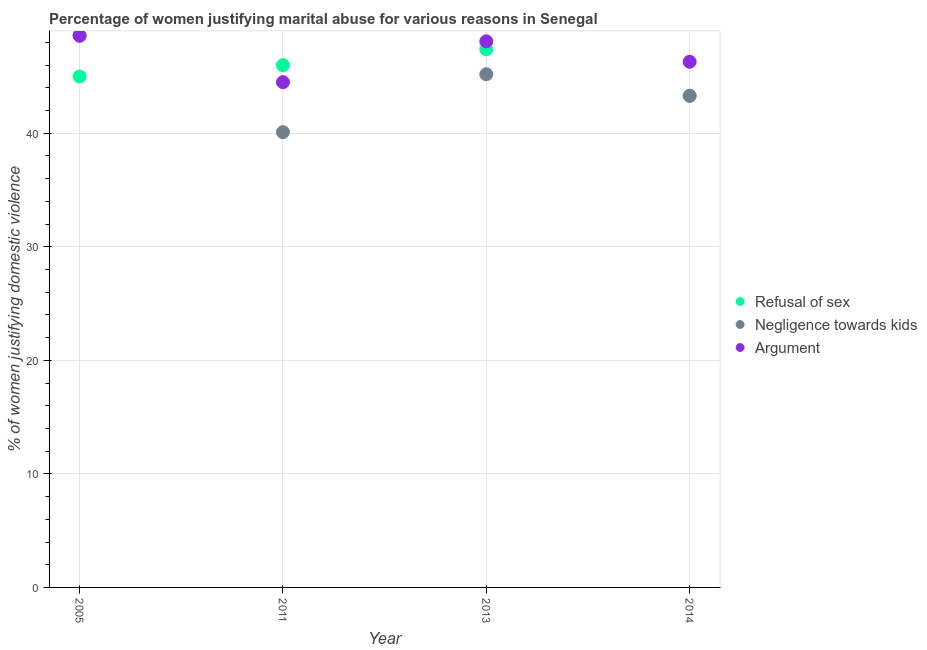What is the percentage of women justifying domestic violence due to arguments in 2011?
Ensure brevity in your answer.  44.5. Across all years, what is the maximum percentage of women justifying domestic violence due to refusal of sex?
Give a very brief answer. 47.4. Across all years, what is the minimum percentage of women justifying domestic violence due to refusal of sex?
Keep it short and to the point. 43.3. In which year was the percentage of women justifying domestic violence due to negligence towards kids maximum?
Your response must be concise. 2005. What is the total percentage of women justifying domestic violence due to arguments in the graph?
Make the answer very short. 187.5. What is the difference between the percentage of women justifying domestic violence due to negligence towards kids in 2011 and that in 2014?
Keep it short and to the point. -3.2. What is the difference between the percentage of women justifying domestic violence due to refusal of sex in 2011 and the percentage of women justifying domestic violence due to negligence towards kids in 2013?
Offer a terse response. 0.8. What is the average percentage of women justifying domestic violence due to negligence towards kids per year?
Your response must be concise. 44.3. In the year 2013, what is the difference between the percentage of women justifying domestic violence due to negligence towards kids and percentage of women justifying domestic violence due to arguments?
Offer a terse response. -2.9. In how many years, is the percentage of women justifying domestic violence due to negligence towards kids greater than 28 %?
Provide a succinct answer. 4. What is the ratio of the percentage of women justifying domestic violence due to negligence towards kids in 2005 to that in 2013?
Your response must be concise. 1.08. Is the difference between the percentage of women justifying domestic violence due to refusal of sex in 2011 and 2013 greater than the difference between the percentage of women justifying domestic violence due to arguments in 2011 and 2013?
Ensure brevity in your answer.  Yes. What is the difference between the highest and the second highest percentage of women justifying domestic violence due to arguments?
Your response must be concise. 0.5. What is the difference between the highest and the lowest percentage of women justifying domestic violence due to negligence towards kids?
Offer a very short reply. 8.5. Is it the case that in every year, the sum of the percentage of women justifying domestic violence due to refusal of sex and percentage of women justifying domestic violence due to negligence towards kids is greater than the percentage of women justifying domestic violence due to arguments?
Give a very brief answer. Yes. How many dotlines are there?
Your response must be concise. 3. How many years are there in the graph?
Keep it short and to the point. 4. What is the difference between two consecutive major ticks on the Y-axis?
Make the answer very short. 10. How many legend labels are there?
Make the answer very short. 3. How are the legend labels stacked?
Your response must be concise. Vertical. What is the title of the graph?
Ensure brevity in your answer.  Percentage of women justifying marital abuse for various reasons in Senegal. What is the label or title of the Y-axis?
Offer a terse response. % of women justifying domestic violence. What is the % of women justifying domestic violence of Refusal of sex in 2005?
Give a very brief answer. 45. What is the % of women justifying domestic violence in Negligence towards kids in 2005?
Give a very brief answer. 48.6. What is the % of women justifying domestic violence of Argument in 2005?
Provide a succinct answer. 48.6. What is the % of women justifying domestic violence in Negligence towards kids in 2011?
Ensure brevity in your answer.  40.1. What is the % of women justifying domestic violence in Argument in 2011?
Make the answer very short. 44.5. What is the % of women justifying domestic violence of Refusal of sex in 2013?
Give a very brief answer. 47.4. What is the % of women justifying domestic violence of Negligence towards kids in 2013?
Offer a terse response. 45.2. What is the % of women justifying domestic violence of Argument in 2013?
Make the answer very short. 48.1. What is the % of women justifying domestic violence of Refusal of sex in 2014?
Provide a short and direct response. 43.3. What is the % of women justifying domestic violence of Negligence towards kids in 2014?
Offer a terse response. 43.3. What is the % of women justifying domestic violence of Argument in 2014?
Your answer should be compact. 46.3. Across all years, what is the maximum % of women justifying domestic violence in Refusal of sex?
Your answer should be compact. 47.4. Across all years, what is the maximum % of women justifying domestic violence in Negligence towards kids?
Offer a very short reply. 48.6. Across all years, what is the maximum % of women justifying domestic violence of Argument?
Offer a very short reply. 48.6. Across all years, what is the minimum % of women justifying domestic violence of Refusal of sex?
Provide a succinct answer. 43.3. Across all years, what is the minimum % of women justifying domestic violence of Negligence towards kids?
Make the answer very short. 40.1. Across all years, what is the minimum % of women justifying domestic violence of Argument?
Give a very brief answer. 44.5. What is the total % of women justifying domestic violence of Refusal of sex in the graph?
Keep it short and to the point. 181.7. What is the total % of women justifying domestic violence in Negligence towards kids in the graph?
Make the answer very short. 177.2. What is the total % of women justifying domestic violence in Argument in the graph?
Give a very brief answer. 187.5. What is the difference between the % of women justifying domestic violence of Refusal of sex in 2005 and that in 2011?
Offer a very short reply. -1. What is the difference between the % of women justifying domestic violence in Refusal of sex in 2005 and that in 2013?
Your answer should be very brief. -2.4. What is the difference between the % of women justifying domestic violence of Argument in 2005 and that in 2013?
Ensure brevity in your answer.  0.5. What is the difference between the % of women justifying domestic violence in Argument in 2005 and that in 2014?
Offer a very short reply. 2.3. What is the difference between the % of women justifying domestic violence of Argument in 2011 and that in 2013?
Keep it short and to the point. -3.6. What is the difference between the % of women justifying domestic violence of Argument in 2011 and that in 2014?
Your response must be concise. -1.8. What is the difference between the % of women justifying domestic violence of Argument in 2013 and that in 2014?
Ensure brevity in your answer.  1.8. What is the difference between the % of women justifying domestic violence of Refusal of sex in 2005 and the % of women justifying domestic violence of Negligence towards kids in 2013?
Provide a short and direct response. -0.2. What is the difference between the % of women justifying domestic violence in Refusal of sex in 2005 and the % of women justifying domestic violence in Negligence towards kids in 2014?
Provide a succinct answer. 1.7. What is the difference between the % of women justifying domestic violence of Refusal of sex in 2005 and the % of women justifying domestic violence of Argument in 2014?
Keep it short and to the point. -1.3. What is the difference between the % of women justifying domestic violence of Refusal of sex in 2011 and the % of women justifying domestic violence of Negligence towards kids in 2013?
Make the answer very short. 0.8. What is the difference between the % of women justifying domestic violence of Refusal of sex in 2011 and the % of women justifying domestic violence of Negligence towards kids in 2014?
Give a very brief answer. 2.7. What is the difference between the % of women justifying domestic violence in Refusal of sex in 2011 and the % of women justifying domestic violence in Argument in 2014?
Give a very brief answer. -0.3. What is the average % of women justifying domestic violence of Refusal of sex per year?
Provide a succinct answer. 45.42. What is the average % of women justifying domestic violence in Negligence towards kids per year?
Offer a very short reply. 44.3. What is the average % of women justifying domestic violence in Argument per year?
Ensure brevity in your answer.  46.88. In the year 2005, what is the difference between the % of women justifying domestic violence in Refusal of sex and % of women justifying domestic violence in Negligence towards kids?
Give a very brief answer. -3.6. In the year 2005, what is the difference between the % of women justifying domestic violence in Refusal of sex and % of women justifying domestic violence in Argument?
Your answer should be very brief. -3.6. In the year 2005, what is the difference between the % of women justifying domestic violence of Negligence towards kids and % of women justifying domestic violence of Argument?
Offer a terse response. 0. In the year 2011, what is the difference between the % of women justifying domestic violence of Refusal of sex and % of women justifying domestic violence of Negligence towards kids?
Ensure brevity in your answer.  5.9. In the year 2011, what is the difference between the % of women justifying domestic violence of Negligence towards kids and % of women justifying domestic violence of Argument?
Provide a succinct answer. -4.4. In the year 2013, what is the difference between the % of women justifying domestic violence in Negligence towards kids and % of women justifying domestic violence in Argument?
Offer a very short reply. -2.9. In the year 2014, what is the difference between the % of women justifying domestic violence of Refusal of sex and % of women justifying domestic violence of Negligence towards kids?
Ensure brevity in your answer.  0. What is the ratio of the % of women justifying domestic violence in Refusal of sex in 2005 to that in 2011?
Give a very brief answer. 0.98. What is the ratio of the % of women justifying domestic violence of Negligence towards kids in 2005 to that in 2011?
Provide a short and direct response. 1.21. What is the ratio of the % of women justifying domestic violence of Argument in 2005 to that in 2011?
Give a very brief answer. 1.09. What is the ratio of the % of women justifying domestic violence of Refusal of sex in 2005 to that in 2013?
Keep it short and to the point. 0.95. What is the ratio of the % of women justifying domestic violence of Negligence towards kids in 2005 to that in 2013?
Keep it short and to the point. 1.08. What is the ratio of the % of women justifying domestic violence of Argument in 2005 to that in 2013?
Provide a short and direct response. 1.01. What is the ratio of the % of women justifying domestic violence in Refusal of sex in 2005 to that in 2014?
Make the answer very short. 1.04. What is the ratio of the % of women justifying domestic violence of Negligence towards kids in 2005 to that in 2014?
Offer a terse response. 1.12. What is the ratio of the % of women justifying domestic violence of Argument in 2005 to that in 2014?
Provide a succinct answer. 1.05. What is the ratio of the % of women justifying domestic violence in Refusal of sex in 2011 to that in 2013?
Keep it short and to the point. 0.97. What is the ratio of the % of women justifying domestic violence in Negligence towards kids in 2011 to that in 2013?
Your answer should be very brief. 0.89. What is the ratio of the % of women justifying domestic violence of Argument in 2011 to that in 2013?
Give a very brief answer. 0.93. What is the ratio of the % of women justifying domestic violence of Refusal of sex in 2011 to that in 2014?
Provide a short and direct response. 1.06. What is the ratio of the % of women justifying domestic violence in Negligence towards kids in 2011 to that in 2014?
Make the answer very short. 0.93. What is the ratio of the % of women justifying domestic violence of Argument in 2011 to that in 2014?
Your answer should be compact. 0.96. What is the ratio of the % of women justifying domestic violence of Refusal of sex in 2013 to that in 2014?
Keep it short and to the point. 1.09. What is the ratio of the % of women justifying domestic violence of Negligence towards kids in 2013 to that in 2014?
Make the answer very short. 1.04. What is the ratio of the % of women justifying domestic violence of Argument in 2013 to that in 2014?
Make the answer very short. 1.04. What is the difference between the highest and the second highest % of women justifying domestic violence in Refusal of sex?
Ensure brevity in your answer.  1.4. What is the difference between the highest and the second highest % of women justifying domestic violence in Negligence towards kids?
Offer a very short reply. 3.4. What is the difference between the highest and the second highest % of women justifying domestic violence of Argument?
Your response must be concise. 0.5. What is the difference between the highest and the lowest % of women justifying domestic violence of Refusal of sex?
Provide a short and direct response. 4.1. What is the difference between the highest and the lowest % of women justifying domestic violence of Negligence towards kids?
Provide a succinct answer. 8.5. 